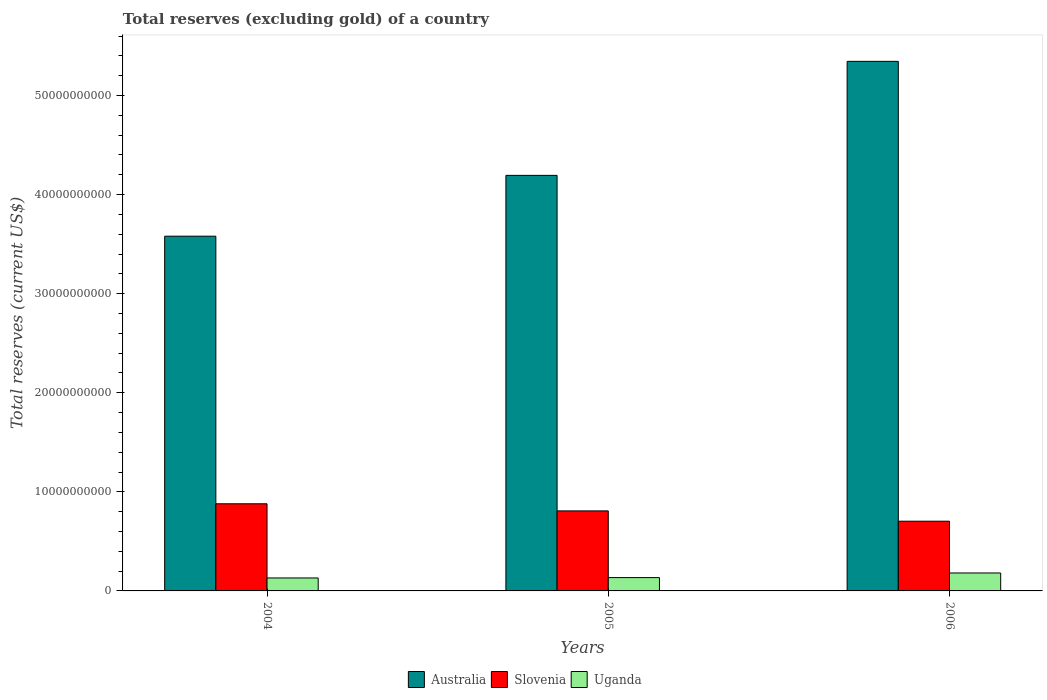Are the number of bars per tick equal to the number of legend labels?
Ensure brevity in your answer.  Yes. Are the number of bars on each tick of the X-axis equal?
Your answer should be very brief. Yes. How many bars are there on the 3rd tick from the left?
Provide a short and direct response. 3. In how many cases, is the number of bars for a given year not equal to the number of legend labels?
Give a very brief answer. 0. What is the total reserves (excluding gold) in Uganda in 2004?
Your answer should be very brief. 1.31e+09. Across all years, what is the maximum total reserves (excluding gold) in Slovenia?
Provide a short and direct response. 8.79e+09. Across all years, what is the minimum total reserves (excluding gold) in Slovenia?
Provide a succinct answer. 7.04e+09. In which year was the total reserves (excluding gold) in Australia minimum?
Keep it short and to the point. 2004. What is the total total reserves (excluding gold) in Slovenia in the graph?
Provide a succinct answer. 2.39e+1. What is the difference between the total reserves (excluding gold) in Uganda in 2004 and that in 2006?
Provide a succinct answer. -5.03e+08. What is the difference between the total reserves (excluding gold) in Australia in 2005 and the total reserves (excluding gold) in Uganda in 2004?
Your answer should be compact. 4.06e+1. What is the average total reserves (excluding gold) in Australia per year?
Offer a very short reply. 4.37e+1. In the year 2006, what is the difference between the total reserves (excluding gold) in Australia and total reserves (excluding gold) in Slovenia?
Your answer should be very brief. 4.64e+1. What is the ratio of the total reserves (excluding gold) in Uganda in 2005 to that in 2006?
Give a very brief answer. 0.74. Is the difference between the total reserves (excluding gold) in Australia in 2004 and 2006 greater than the difference between the total reserves (excluding gold) in Slovenia in 2004 and 2006?
Provide a succinct answer. No. What is the difference between the highest and the second highest total reserves (excluding gold) in Australia?
Provide a short and direct response. 1.15e+1. What is the difference between the highest and the lowest total reserves (excluding gold) in Slovenia?
Provide a succinct answer. 1.76e+09. In how many years, is the total reserves (excluding gold) in Uganda greater than the average total reserves (excluding gold) in Uganda taken over all years?
Offer a terse response. 1. What does the 2nd bar from the left in 2006 represents?
Ensure brevity in your answer.  Slovenia. What does the 2nd bar from the right in 2004 represents?
Offer a terse response. Slovenia. Is it the case that in every year, the sum of the total reserves (excluding gold) in Australia and total reserves (excluding gold) in Uganda is greater than the total reserves (excluding gold) in Slovenia?
Your answer should be very brief. Yes. How many years are there in the graph?
Ensure brevity in your answer.  3. Are the values on the major ticks of Y-axis written in scientific E-notation?
Ensure brevity in your answer.  No. Does the graph contain grids?
Provide a short and direct response. No. How many legend labels are there?
Provide a succinct answer. 3. What is the title of the graph?
Your response must be concise. Total reserves (excluding gold) of a country. What is the label or title of the X-axis?
Offer a very short reply. Years. What is the label or title of the Y-axis?
Your answer should be compact. Total reserves (current US$). What is the Total reserves (current US$) in Australia in 2004?
Your response must be concise. 3.58e+1. What is the Total reserves (current US$) in Slovenia in 2004?
Provide a succinct answer. 8.79e+09. What is the Total reserves (current US$) of Uganda in 2004?
Ensure brevity in your answer.  1.31e+09. What is the Total reserves (current US$) in Australia in 2005?
Make the answer very short. 4.19e+1. What is the Total reserves (current US$) in Slovenia in 2005?
Keep it short and to the point. 8.08e+09. What is the Total reserves (current US$) in Uganda in 2005?
Offer a very short reply. 1.34e+09. What is the Total reserves (current US$) of Australia in 2006?
Give a very brief answer. 5.34e+1. What is the Total reserves (current US$) of Slovenia in 2006?
Keep it short and to the point. 7.04e+09. What is the Total reserves (current US$) in Uganda in 2006?
Your answer should be very brief. 1.81e+09. Across all years, what is the maximum Total reserves (current US$) in Australia?
Your answer should be compact. 5.34e+1. Across all years, what is the maximum Total reserves (current US$) in Slovenia?
Ensure brevity in your answer.  8.79e+09. Across all years, what is the maximum Total reserves (current US$) in Uganda?
Your answer should be very brief. 1.81e+09. Across all years, what is the minimum Total reserves (current US$) of Australia?
Your response must be concise. 3.58e+1. Across all years, what is the minimum Total reserves (current US$) in Slovenia?
Make the answer very short. 7.04e+09. Across all years, what is the minimum Total reserves (current US$) of Uganda?
Provide a short and direct response. 1.31e+09. What is the total Total reserves (current US$) of Australia in the graph?
Give a very brief answer. 1.31e+11. What is the total Total reserves (current US$) of Slovenia in the graph?
Keep it short and to the point. 2.39e+1. What is the total Total reserves (current US$) in Uganda in the graph?
Provide a succinct answer. 4.46e+09. What is the difference between the Total reserves (current US$) of Australia in 2004 and that in 2005?
Provide a short and direct response. -6.14e+09. What is the difference between the Total reserves (current US$) in Slovenia in 2004 and that in 2005?
Your answer should be very brief. 7.17e+08. What is the difference between the Total reserves (current US$) in Uganda in 2004 and that in 2005?
Offer a terse response. -3.61e+07. What is the difference between the Total reserves (current US$) in Australia in 2004 and that in 2006?
Ensure brevity in your answer.  -1.76e+1. What is the difference between the Total reserves (current US$) of Slovenia in 2004 and that in 2006?
Provide a succinct answer. 1.76e+09. What is the difference between the Total reserves (current US$) in Uganda in 2004 and that in 2006?
Your response must be concise. -5.03e+08. What is the difference between the Total reserves (current US$) in Australia in 2005 and that in 2006?
Offer a very short reply. -1.15e+1. What is the difference between the Total reserves (current US$) in Slovenia in 2005 and that in 2006?
Keep it short and to the point. 1.04e+09. What is the difference between the Total reserves (current US$) of Uganda in 2005 and that in 2006?
Give a very brief answer. -4.67e+08. What is the difference between the Total reserves (current US$) in Australia in 2004 and the Total reserves (current US$) in Slovenia in 2005?
Your response must be concise. 2.77e+1. What is the difference between the Total reserves (current US$) in Australia in 2004 and the Total reserves (current US$) in Uganda in 2005?
Your response must be concise. 3.45e+1. What is the difference between the Total reserves (current US$) of Slovenia in 2004 and the Total reserves (current US$) of Uganda in 2005?
Give a very brief answer. 7.45e+09. What is the difference between the Total reserves (current US$) of Australia in 2004 and the Total reserves (current US$) of Slovenia in 2006?
Provide a succinct answer. 2.88e+1. What is the difference between the Total reserves (current US$) of Australia in 2004 and the Total reserves (current US$) of Uganda in 2006?
Make the answer very short. 3.40e+1. What is the difference between the Total reserves (current US$) of Slovenia in 2004 and the Total reserves (current US$) of Uganda in 2006?
Offer a very short reply. 6.98e+09. What is the difference between the Total reserves (current US$) in Australia in 2005 and the Total reserves (current US$) in Slovenia in 2006?
Make the answer very short. 3.49e+1. What is the difference between the Total reserves (current US$) in Australia in 2005 and the Total reserves (current US$) in Uganda in 2006?
Give a very brief answer. 4.01e+1. What is the difference between the Total reserves (current US$) in Slovenia in 2005 and the Total reserves (current US$) in Uganda in 2006?
Provide a succinct answer. 6.27e+09. What is the average Total reserves (current US$) of Australia per year?
Your answer should be compact. 4.37e+1. What is the average Total reserves (current US$) in Slovenia per year?
Your answer should be very brief. 7.97e+09. What is the average Total reserves (current US$) of Uganda per year?
Offer a very short reply. 1.49e+09. In the year 2004, what is the difference between the Total reserves (current US$) in Australia and Total reserves (current US$) in Slovenia?
Ensure brevity in your answer.  2.70e+1. In the year 2004, what is the difference between the Total reserves (current US$) in Australia and Total reserves (current US$) in Uganda?
Provide a succinct answer. 3.45e+1. In the year 2004, what is the difference between the Total reserves (current US$) of Slovenia and Total reserves (current US$) of Uganda?
Offer a terse response. 7.49e+09. In the year 2005, what is the difference between the Total reserves (current US$) in Australia and Total reserves (current US$) in Slovenia?
Provide a short and direct response. 3.39e+1. In the year 2005, what is the difference between the Total reserves (current US$) of Australia and Total reserves (current US$) of Uganda?
Offer a very short reply. 4.06e+1. In the year 2005, what is the difference between the Total reserves (current US$) of Slovenia and Total reserves (current US$) of Uganda?
Provide a succinct answer. 6.73e+09. In the year 2006, what is the difference between the Total reserves (current US$) of Australia and Total reserves (current US$) of Slovenia?
Your response must be concise. 4.64e+1. In the year 2006, what is the difference between the Total reserves (current US$) of Australia and Total reserves (current US$) of Uganda?
Your response must be concise. 5.16e+1. In the year 2006, what is the difference between the Total reserves (current US$) in Slovenia and Total reserves (current US$) in Uganda?
Your answer should be compact. 5.23e+09. What is the ratio of the Total reserves (current US$) of Australia in 2004 to that in 2005?
Your answer should be compact. 0.85. What is the ratio of the Total reserves (current US$) of Slovenia in 2004 to that in 2005?
Ensure brevity in your answer.  1.09. What is the ratio of the Total reserves (current US$) in Uganda in 2004 to that in 2005?
Offer a very short reply. 0.97. What is the ratio of the Total reserves (current US$) in Australia in 2004 to that in 2006?
Offer a very short reply. 0.67. What is the ratio of the Total reserves (current US$) in Slovenia in 2004 to that in 2006?
Give a very brief answer. 1.25. What is the ratio of the Total reserves (current US$) in Uganda in 2004 to that in 2006?
Your answer should be very brief. 0.72. What is the ratio of the Total reserves (current US$) in Australia in 2005 to that in 2006?
Offer a terse response. 0.78. What is the ratio of the Total reserves (current US$) of Slovenia in 2005 to that in 2006?
Your answer should be very brief. 1.15. What is the ratio of the Total reserves (current US$) of Uganda in 2005 to that in 2006?
Give a very brief answer. 0.74. What is the difference between the highest and the second highest Total reserves (current US$) of Australia?
Your answer should be compact. 1.15e+1. What is the difference between the highest and the second highest Total reserves (current US$) of Slovenia?
Provide a succinct answer. 7.17e+08. What is the difference between the highest and the second highest Total reserves (current US$) of Uganda?
Provide a short and direct response. 4.67e+08. What is the difference between the highest and the lowest Total reserves (current US$) in Australia?
Your answer should be very brief. 1.76e+1. What is the difference between the highest and the lowest Total reserves (current US$) in Slovenia?
Provide a short and direct response. 1.76e+09. What is the difference between the highest and the lowest Total reserves (current US$) in Uganda?
Provide a succinct answer. 5.03e+08. 